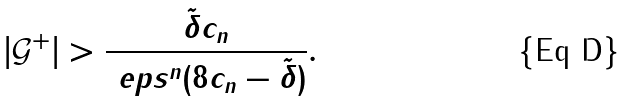Convert formula to latex. <formula><loc_0><loc_0><loc_500><loc_500>| \mathcal { G } ^ { + } | > \frac { \tilde { \delta } c _ { n } } { \ e p s ^ { n } ( 8 c _ { n } - \tilde { \delta } ) } .</formula> 